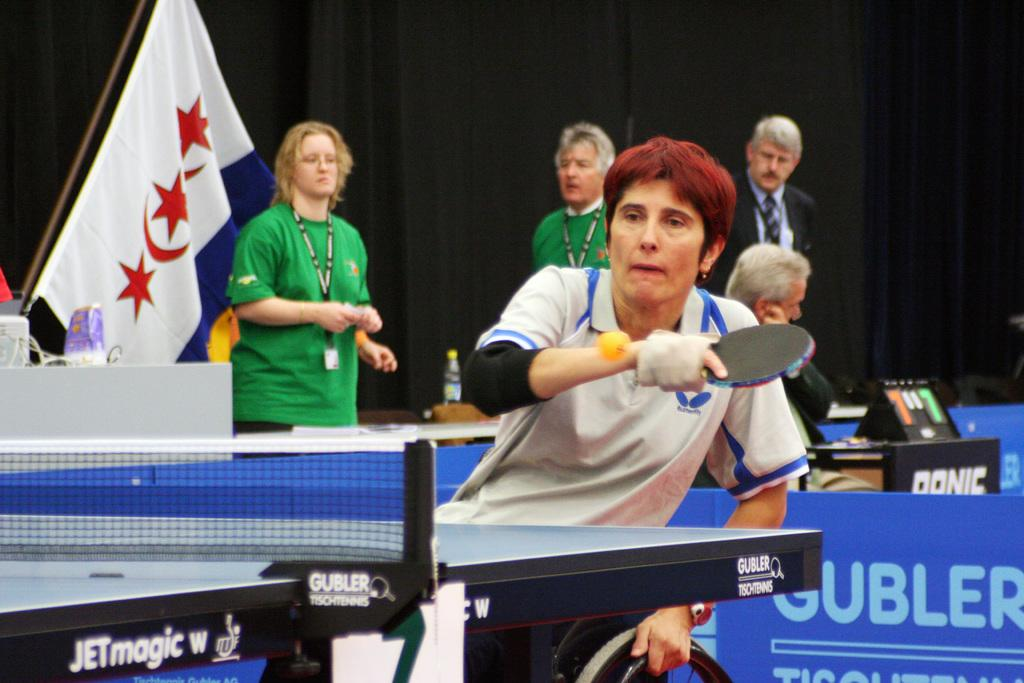What activity is the man in the image engaged in? The man is playing table tennis in the image. Can you describe the scene behind the man? There are other people and a flag in the backdrop of the image, along with a black curtain. What type of crack is present in the image? There is no crack present in the image. What industry is depicted in the image? The image does not depict any specific industry; it shows a man playing table tennis and a backdrop with people, a flag, and a black curtain. 